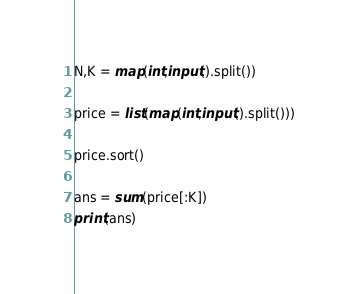<code> <loc_0><loc_0><loc_500><loc_500><_Python_>N,K = map(int,input().split())

price = list(map(int,input().split()))

price.sort()

ans = sum(price[:K])
print(ans)
</code> 